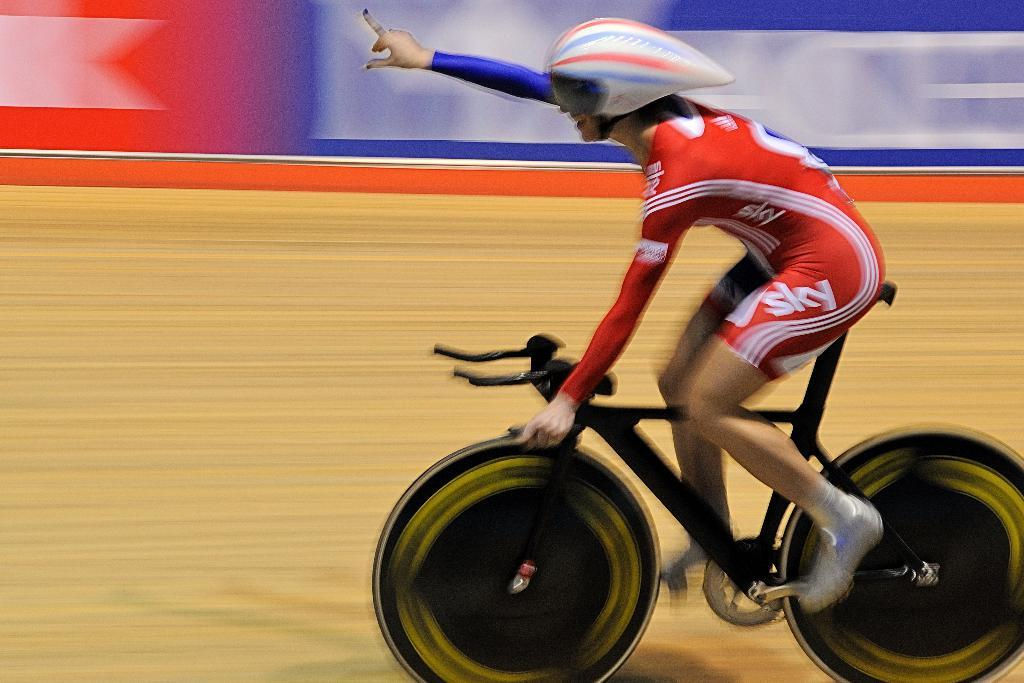<image>
Offer a succinct explanation of the picture presented. A person in a bikrace with the word sky on their leg 